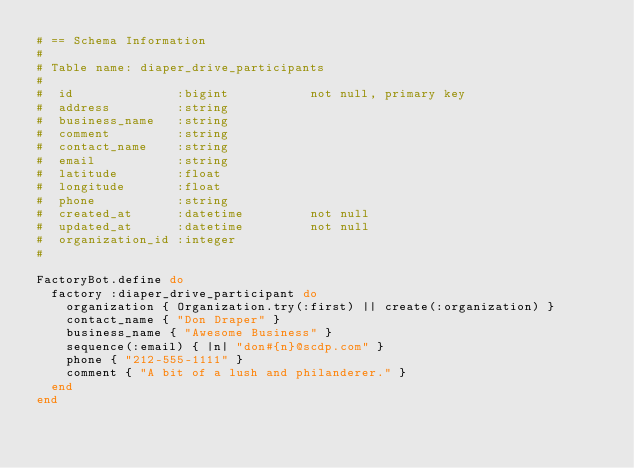Convert code to text. <code><loc_0><loc_0><loc_500><loc_500><_Ruby_># == Schema Information
#
# Table name: diaper_drive_participants
#
#  id              :bigint           not null, primary key
#  address         :string
#  business_name   :string
#  comment         :string
#  contact_name    :string
#  email           :string
#  latitude        :float
#  longitude       :float
#  phone           :string
#  created_at      :datetime         not null
#  updated_at      :datetime         not null
#  organization_id :integer
#

FactoryBot.define do
  factory :diaper_drive_participant do
    organization { Organization.try(:first) || create(:organization) }
    contact_name { "Don Draper" }
    business_name { "Awesome Business" }
    sequence(:email) { |n| "don#{n}@scdp.com" }
    phone { "212-555-1111" }
    comment { "A bit of a lush and philanderer." }
  end
end
</code> 